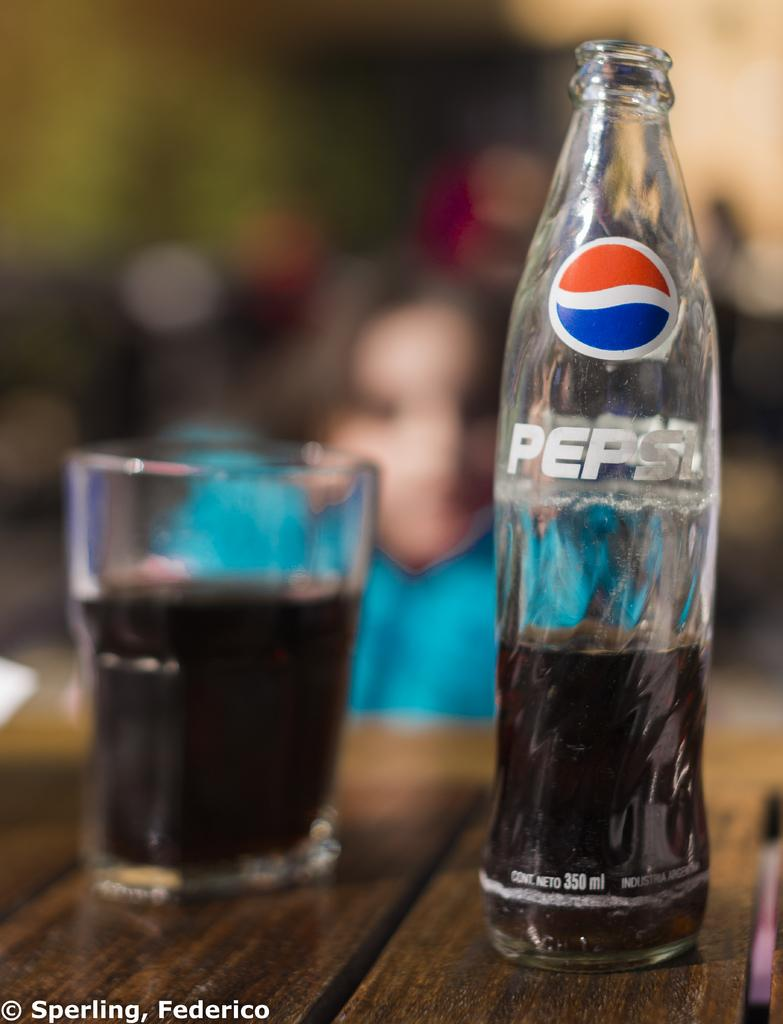What is on the table in the image? There is a bottle and a glass with liquid on the table. What is in the glass? The glass contains liquid. Can you describe the person in the background of the image? The person in the background is wearing blue. What type of jewel can be seen in the image? There is no jewel present in the image. What kind of shade is covering the table in the image? There is no shade covering the table in the image. 